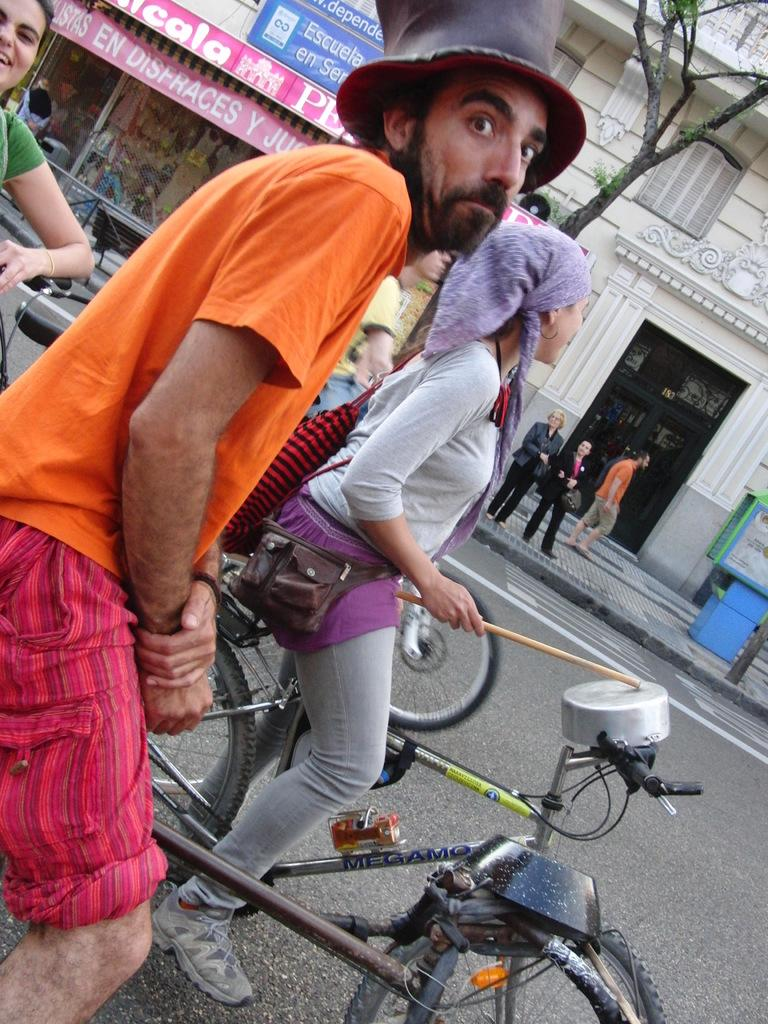What are the persons doing in the image? The persons are standing on a bicycle. What can be seen in the background of the image? There are stores beside them. What type of waste can be seen in the image? There is no waste visible in the image. What account might the persons have opened at the nearby stores? There is no information about any accounts in the image. 